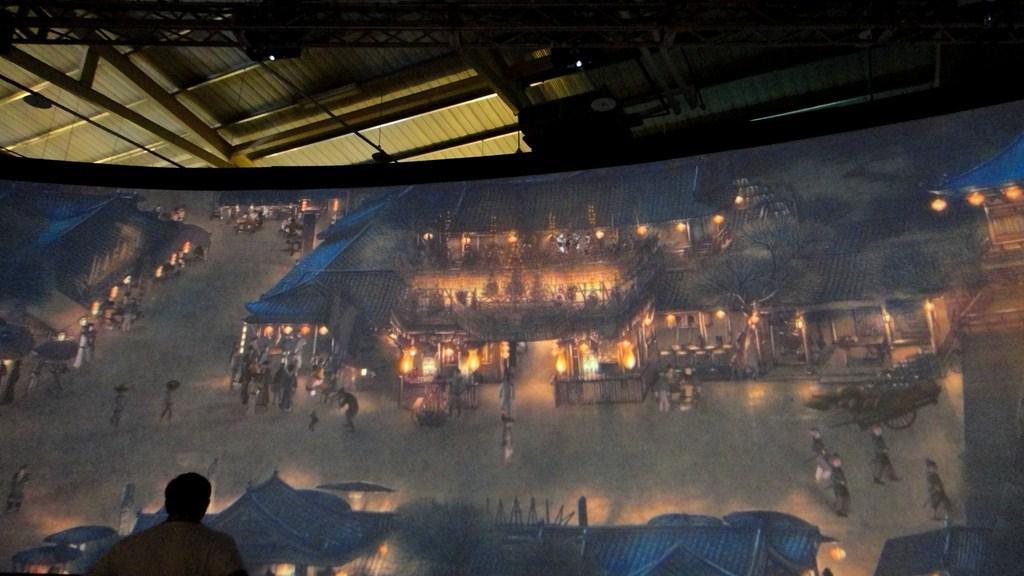Can you describe this image briefly? In this image, we can see a banner and on the banner, we can see sheds, people, lights, trees and there are vehicles on the road. At the top, there is a roof and we can see lights and rods. At the bottom, there is a person. 